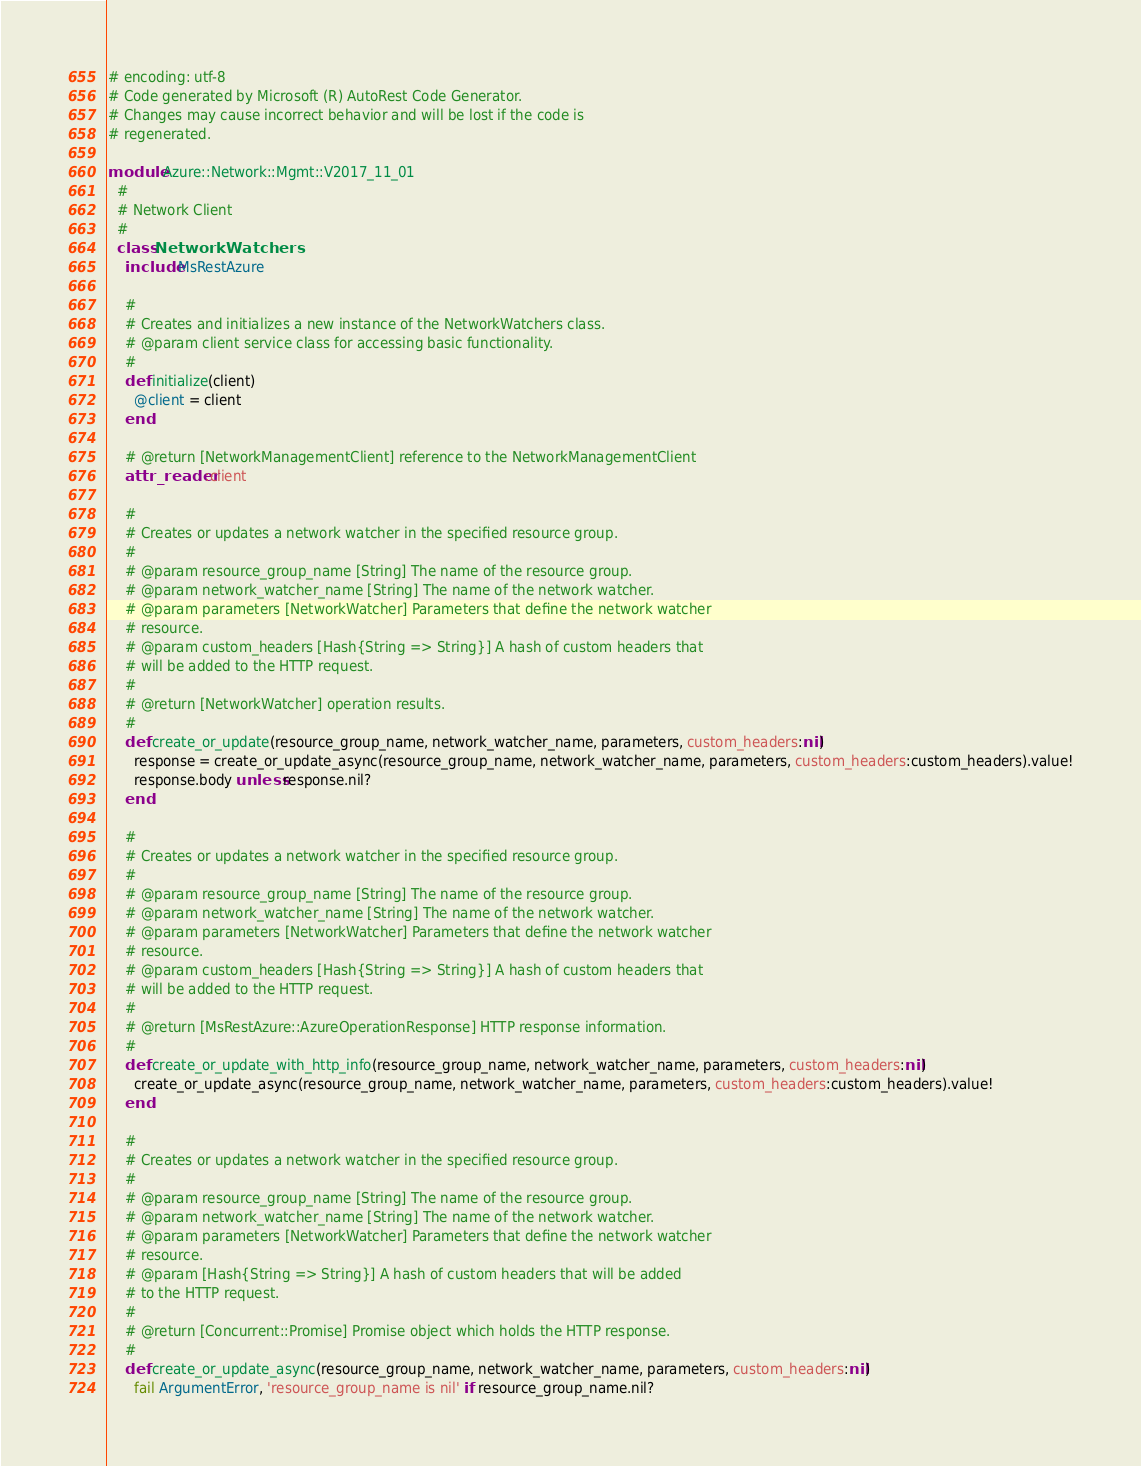Convert code to text. <code><loc_0><loc_0><loc_500><loc_500><_Ruby_># encoding: utf-8
# Code generated by Microsoft (R) AutoRest Code Generator.
# Changes may cause incorrect behavior and will be lost if the code is
# regenerated.

module Azure::Network::Mgmt::V2017_11_01
  #
  # Network Client
  #
  class NetworkWatchers
    include MsRestAzure

    #
    # Creates and initializes a new instance of the NetworkWatchers class.
    # @param client service class for accessing basic functionality.
    #
    def initialize(client)
      @client = client
    end

    # @return [NetworkManagementClient] reference to the NetworkManagementClient
    attr_reader :client

    #
    # Creates or updates a network watcher in the specified resource group.
    #
    # @param resource_group_name [String] The name of the resource group.
    # @param network_watcher_name [String] The name of the network watcher.
    # @param parameters [NetworkWatcher] Parameters that define the network watcher
    # resource.
    # @param custom_headers [Hash{String => String}] A hash of custom headers that
    # will be added to the HTTP request.
    #
    # @return [NetworkWatcher] operation results.
    #
    def create_or_update(resource_group_name, network_watcher_name, parameters, custom_headers:nil)
      response = create_or_update_async(resource_group_name, network_watcher_name, parameters, custom_headers:custom_headers).value!
      response.body unless response.nil?
    end

    #
    # Creates or updates a network watcher in the specified resource group.
    #
    # @param resource_group_name [String] The name of the resource group.
    # @param network_watcher_name [String] The name of the network watcher.
    # @param parameters [NetworkWatcher] Parameters that define the network watcher
    # resource.
    # @param custom_headers [Hash{String => String}] A hash of custom headers that
    # will be added to the HTTP request.
    #
    # @return [MsRestAzure::AzureOperationResponse] HTTP response information.
    #
    def create_or_update_with_http_info(resource_group_name, network_watcher_name, parameters, custom_headers:nil)
      create_or_update_async(resource_group_name, network_watcher_name, parameters, custom_headers:custom_headers).value!
    end

    #
    # Creates or updates a network watcher in the specified resource group.
    #
    # @param resource_group_name [String] The name of the resource group.
    # @param network_watcher_name [String] The name of the network watcher.
    # @param parameters [NetworkWatcher] Parameters that define the network watcher
    # resource.
    # @param [Hash{String => String}] A hash of custom headers that will be added
    # to the HTTP request.
    #
    # @return [Concurrent::Promise] Promise object which holds the HTTP response.
    #
    def create_or_update_async(resource_group_name, network_watcher_name, parameters, custom_headers:nil)
      fail ArgumentError, 'resource_group_name is nil' if resource_group_name.nil?</code> 